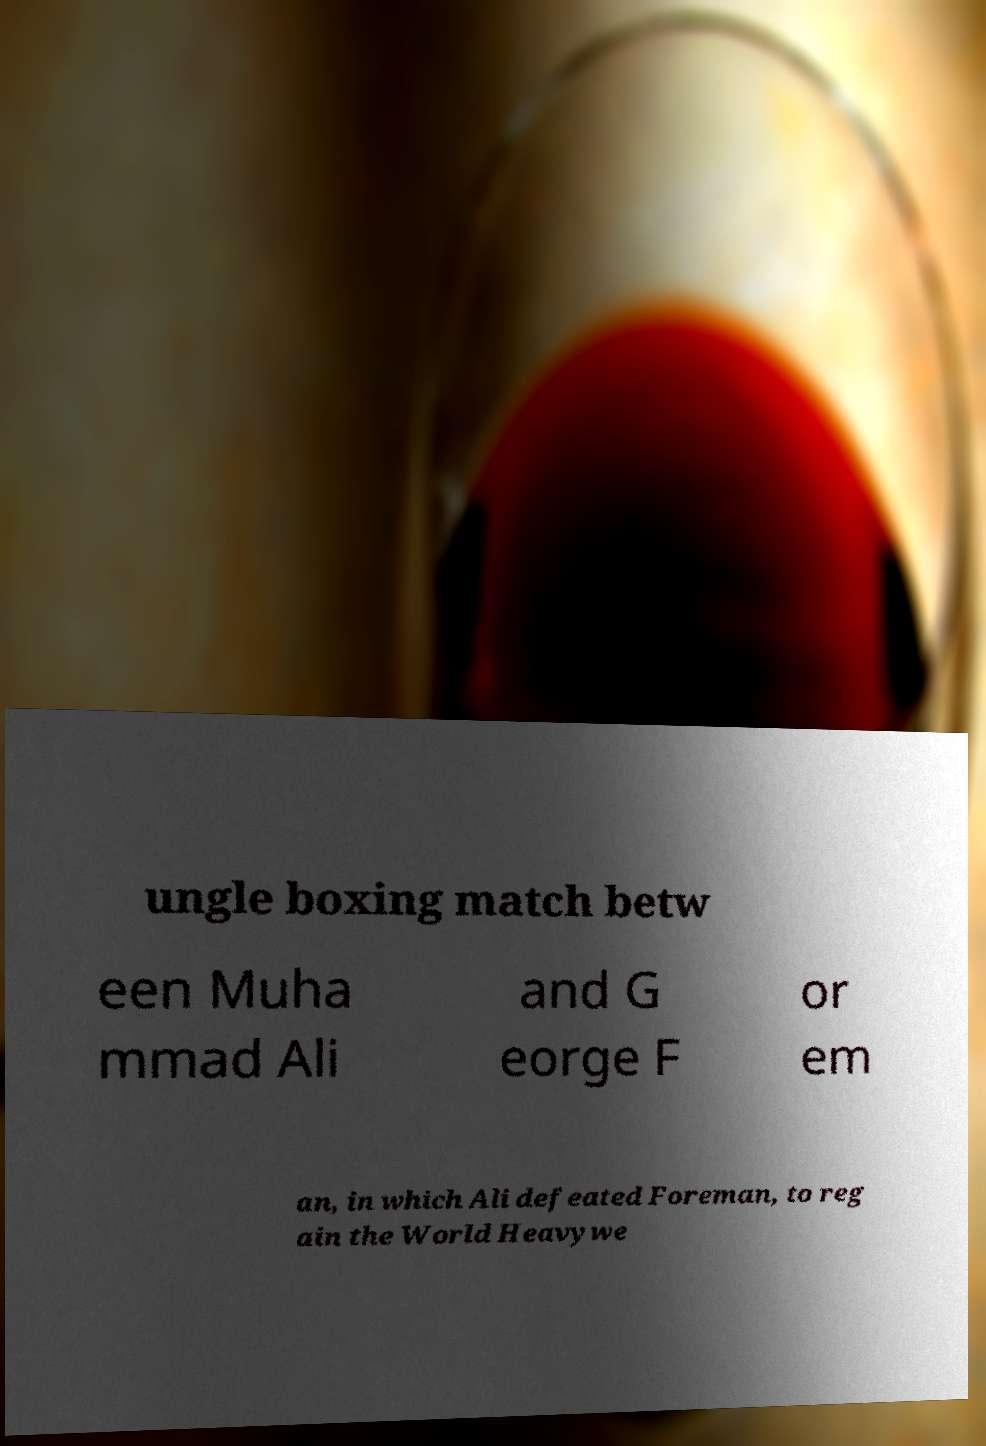For documentation purposes, I need the text within this image transcribed. Could you provide that? ungle boxing match betw een Muha mmad Ali and G eorge F or em an, in which Ali defeated Foreman, to reg ain the World Heavywe 